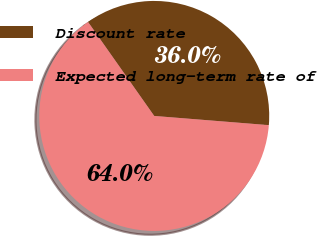Convert chart. <chart><loc_0><loc_0><loc_500><loc_500><pie_chart><fcel>Discount rate<fcel>Expected long-term rate of<nl><fcel>36.04%<fcel>63.96%<nl></chart> 